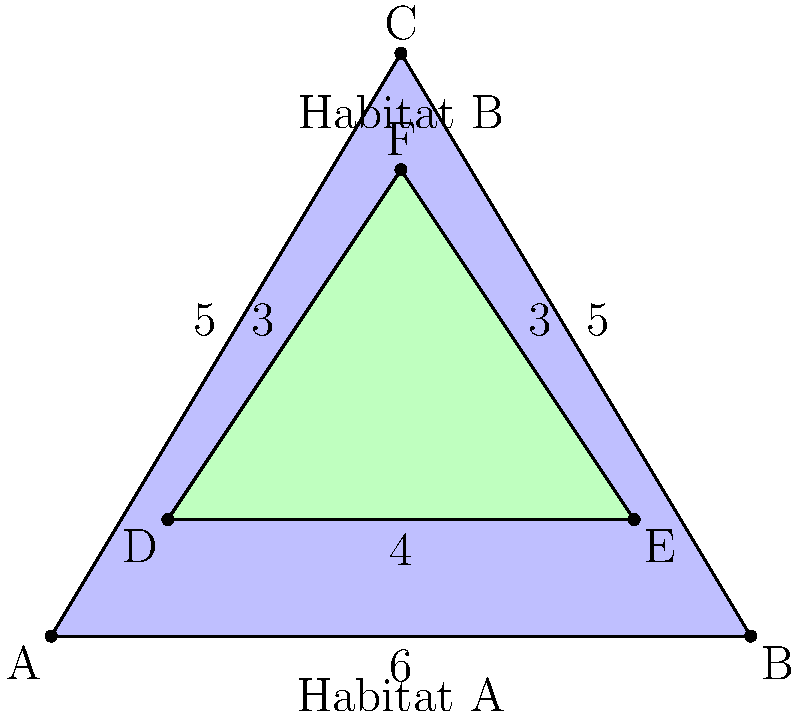In a wildlife conservation study, two overlapping habitats are represented by triangles as shown in the diagram. Habitat A is represented by triangle ABC, and Habitat B is represented by triangle DEF. The dimensions of the triangles are given in kilometers. What is the area of the overlapping region between the two habitats? To find the area of the overlapping region, we need to:

1. Calculate the area of both triangles.
2. Find the area of the overlapping region by subtracting the areas of the non-overlapping parts from the total area of both triangles.

Step 1: Calculate the areas of the triangles
For triangle ABC (Habitat A):
Area = $\frac{1}{2} \times base \times height = \frac{1}{2} \times 6 \times 5 = 15$ sq km

For triangle DEF (Habitat B):
Area = $\frac{1}{2} \times base \times height = \frac{1}{2} \times 4 \times 3 = 6$ sq km

Step 2: Find the area of the non-overlapping parts
The non-overlapping parts are the areas of the triangles outside the intersection.

For triangle ABC:
Non-overlapping area = Area of ABC - Area of intersection
For triangle DEF:
Non-overlapping area = Area of DEF - Area of intersection

Total non-overlapping area = (15 - x) + (6 - x) = 21 - 2x, where x is the area of intersection.

Step 3: Set up an equation
Total area = Area of ABC + Area of DEF - Area of intersection
21 = 15 + 6 - x

Step 4: Solve for x (area of intersection)
21 = 21 - x
x = 0

Therefore, the area of the overlapping region is 0 sq km.
Answer: 0 sq km 